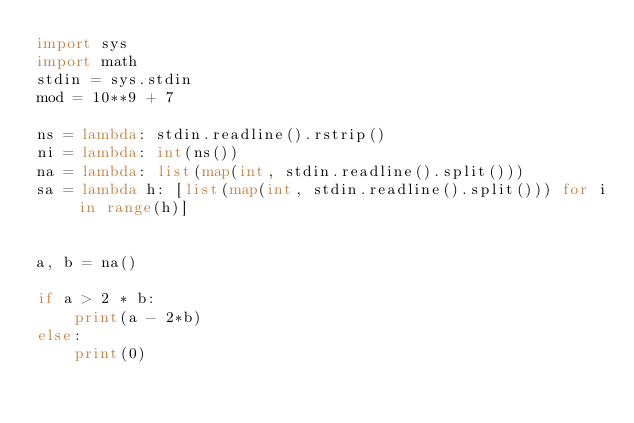Convert code to text. <code><loc_0><loc_0><loc_500><loc_500><_Python_>import sys
import math
stdin = sys.stdin
mod = 10**9 + 7

ns = lambda: stdin.readline().rstrip()
ni = lambda: int(ns())
na = lambda: list(map(int, stdin.readline().split()))
sa = lambda h: [list(map(int, stdin.readline().split())) for i in range(h)]


a, b = na()

if a > 2 * b:
    print(a - 2*b)
else:
    print(0)</code> 